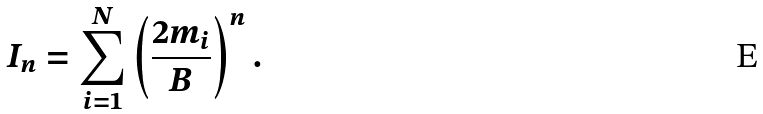Convert formula to latex. <formula><loc_0><loc_0><loc_500><loc_500>I _ { n } = \sum _ { i = 1 } ^ { N } \left ( \frac { 2 m _ { i } } { B } \right ) ^ { n } .</formula> 